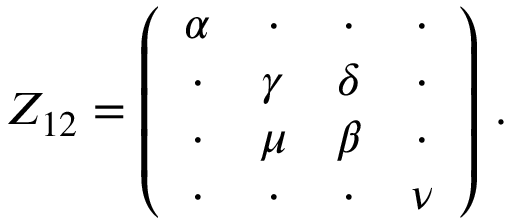Convert formula to latex. <formula><loc_0><loc_0><loc_500><loc_500>Z _ { 1 2 } = \left ( \begin{array} { c c c c } { \alpha } & { \cdot } & { \cdot } & { \cdot } \\ { \cdot } & { \gamma } & { \delta } & { \cdot } \\ { \cdot } & { \mu } & { \beta } & { \cdot } \\ { \cdot } & { \cdot } & { \cdot } & { \nu } \end{array} \right ) \, .</formula> 